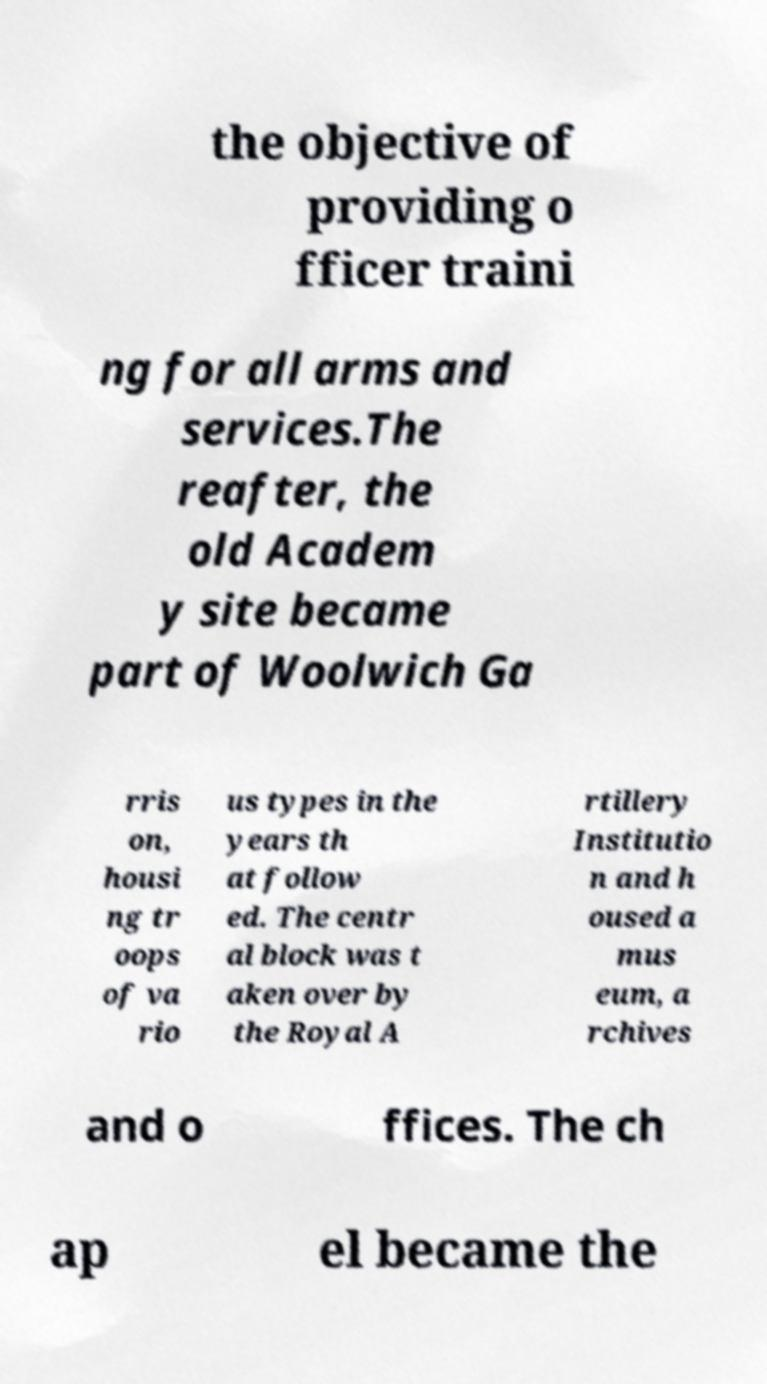Please read and relay the text visible in this image. What does it say? the objective of providing o fficer traini ng for all arms and services.The reafter, the old Academ y site became part of Woolwich Ga rris on, housi ng tr oops of va rio us types in the years th at follow ed. The centr al block was t aken over by the Royal A rtillery Institutio n and h oused a mus eum, a rchives and o ffices. The ch ap el became the 